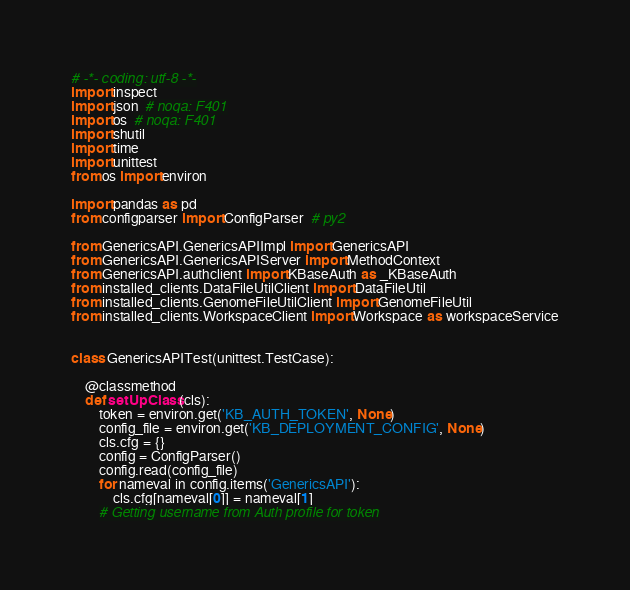Convert code to text. <code><loc_0><loc_0><loc_500><loc_500><_Python_># -*- coding: utf-8 -*-
import inspect
import json  # noqa: F401
import os  # noqa: F401
import shutil
import time
import unittest
from os import environ

import pandas as pd
from configparser import ConfigParser  # py2

from GenericsAPI.GenericsAPIImpl import GenericsAPI
from GenericsAPI.GenericsAPIServer import MethodContext
from GenericsAPI.authclient import KBaseAuth as _KBaseAuth
from installed_clients.DataFileUtilClient import DataFileUtil
from installed_clients.GenomeFileUtilClient import GenomeFileUtil
from installed_clients.WorkspaceClient import Workspace as workspaceService


class GenericsAPITest(unittest.TestCase):

    @classmethod
    def setUpClass(cls):
        token = environ.get('KB_AUTH_TOKEN', None)
        config_file = environ.get('KB_DEPLOYMENT_CONFIG', None)
        cls.cfg = {}
        config = ConfigParser()
        config.read(config_file)
        for nameval in config.items('GenericsAPI'):
            cls.cfg[nameval[0]] = nameval[1]
        # Getting username from Auth profile for token</code> 